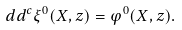Convert formula to latex. <formula><loc_0><loc_0><loc_500><loc_500>d d ^ { c } \xi ^ { 0 } ( X , z ) = \varphi ^ { 0 } ( X , z ) .</formula> 